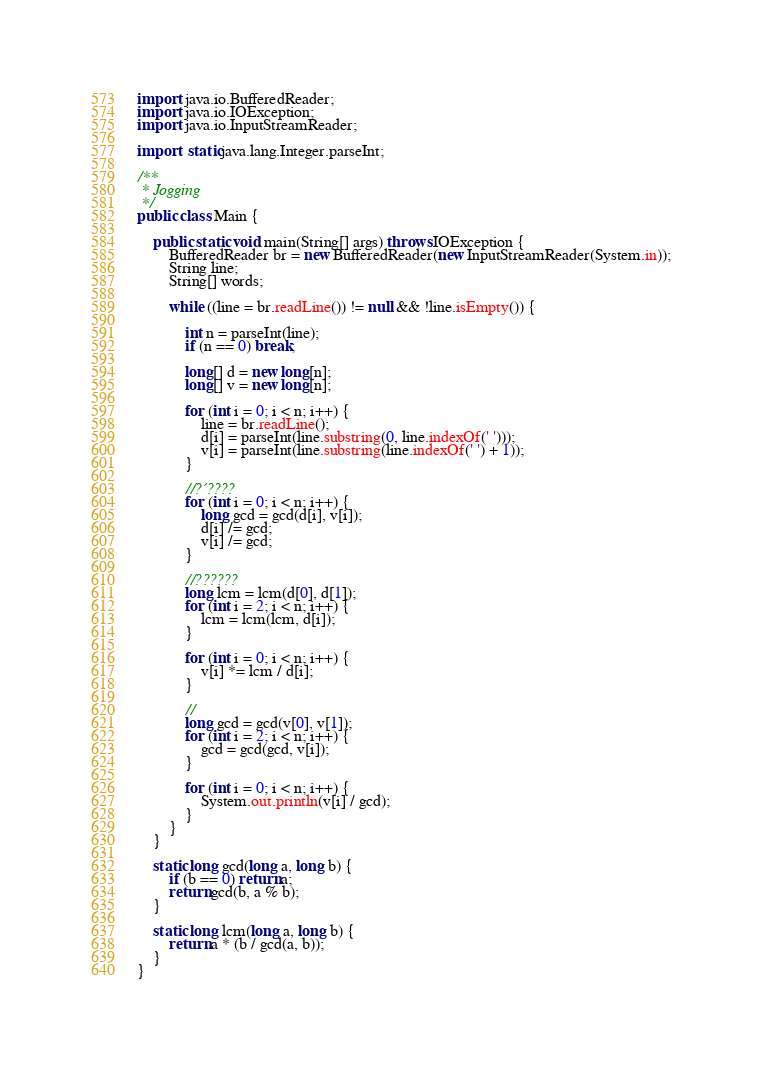<code> <loc_0><loc_0><loc_500><loc_500><_Java_>import java.io.BufferedReader;
import java.io.IOException;
import java.io.InputStreamReader;

import static java.lang.Integer.parseInt;

/**
 * Jogging
 */
public class Main {

	public static void main(String[] args) throws IOException {
		BufferedReader br = new BufferedReader(new InputStreamReader(System.in));
		String line;
		String[] words;

		while ((line = br.readLine()) != null && !line.isEmpty()) {

			int n = parseInt(line);
			if (n == 0) break;

			long[] d = new long[n];
			long[] v = new long[n];

			for (int i = 0; i < n; i++) {
				line = br.readLine();
				d[i] = parseInt(line.substring(0, line.indexOf(' ')));
				v[i] = parseInt(line.substring(line.indexOf(' ') + 1));
			}

			//?´????
			for (int i = 0; i < n; i++) {
				long gcd = gcd(d[i], v[i]);
				d[i] /= gcd;
				v[i] /= gcd;
			}

			//??????
			long lcm = lcm(d[0], d[1]);
			for (int i = 2; i < n; i++) {
				lcm = lcm(lcm, d[i]);
			}

			for (int i = 0; i < n; i++) {
				v[i] *= lcm / d[i];
			}

			//
			long gcd = gcd(v[0], v[1]);
			for (int i = 2; i < n; i++) {
				gcd = gcd(gcd, v[i]);
			}

			for (int i = 0; i < n; i++) {
				System.out.println(v[i] / gcd);
			}
		}
	}

	static long gcd(long a, long b) {
		if (b == 0) return a;
		return gcd(b, a % b);
	}

	static long lcm(long a, long b) {
		return a * (b / gcd(a, b));
	}
}</code> 